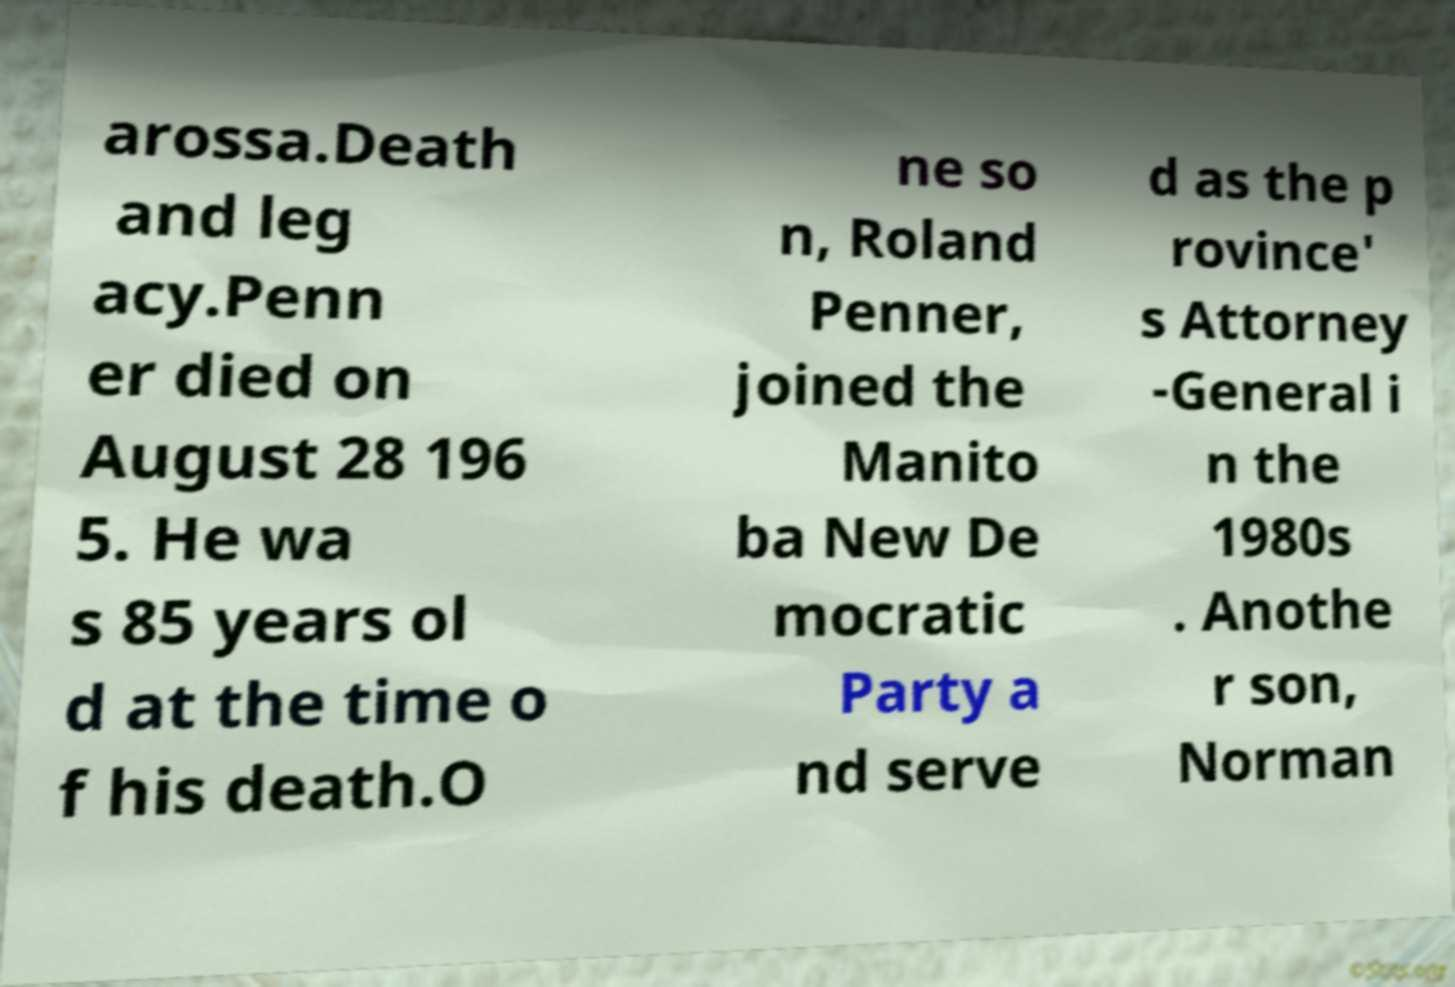What messages or text are displayed in this image? I need them in a readable, typed format. arossa.Death and leg acy.Penn er died on August 28 196 5. He wa s 85 years ol d at the time o f his death.O ne so n, Roland Penner, joined the Manito ba New De mocratic Party a nd serve d as the p rovince' s Attorney -General i n the 1980s . Anothe r son, Norman 